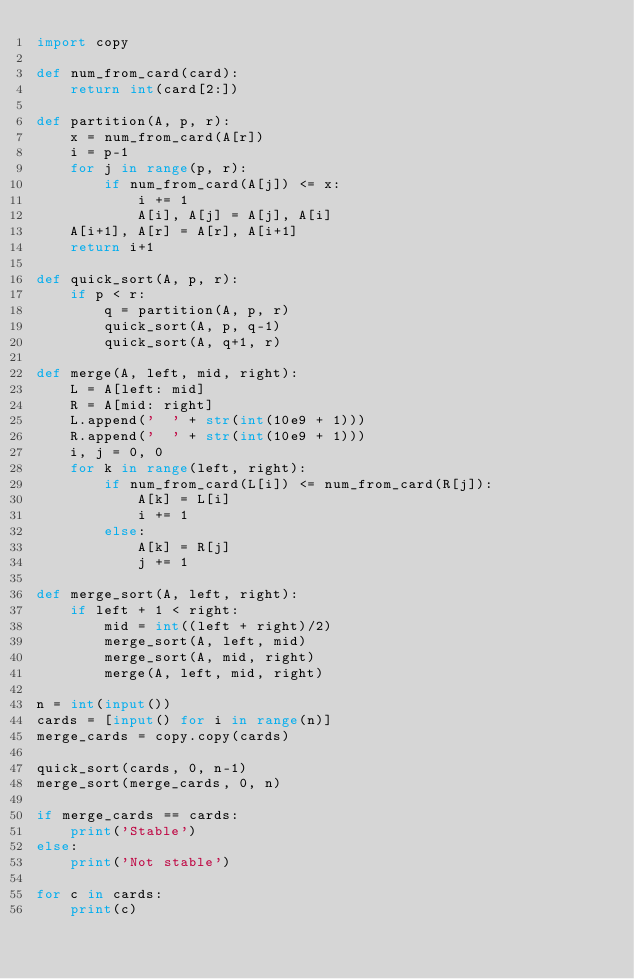Convert code to text. <code><loc_0><loc_0><loc_500><loc_500><_Python_>import copy

def num_from_card(card):
    return int(card[2:])

def partition(A, p, r):
    x = num_from_card(A[r])
    i = p-1
    for j in range(p, r):
        if num_from_card(A[j]) <= x:
            i += 1
            A[i], A[j] = A[j], A[i]
    A[i+1], A[r] = A[r], A[i+1]
    return i+1

def quick_sort(A, p, r):
    if p < r:
        q = partition(A, p, r)
        quick_sort(A, p, q-1)
        quick_sort(A, q+1, r)

def merge(A, left, mid, right):
    L = A[left: mid]
    R = A[mid: right]
    L.append('  ' + str(int(10e9 + 1)))
    R.append('  ' + str(int(10e9 + 1)))
    i, j = 0, 0
    for k in range(left, right):
        if num_from_card(L[i]) <= num_from_card(R[j]):
            A[k] = L[i]
            i += 1
        else:
            A[k] = R[j]
            j += 1

def merge_sort(A, left, right):
    if left + 1 < right:
        mid = int((left + right)/2)
        merge_sort(A, left, mid)
        merge_sort(A, mid, right)
        merge(A, left, mid, right)

n = int(input())
cards = [input() for i in range(n)]
merge_cards = copy.copy(cards)

quick_sort(cards, 0, n-1)
merge_sort(merge_cards, 0, n)

if merge_cards == cards:
    print('Stable')
else:
    print('Not stable')

for c in cards:
    print(c)

</code> 